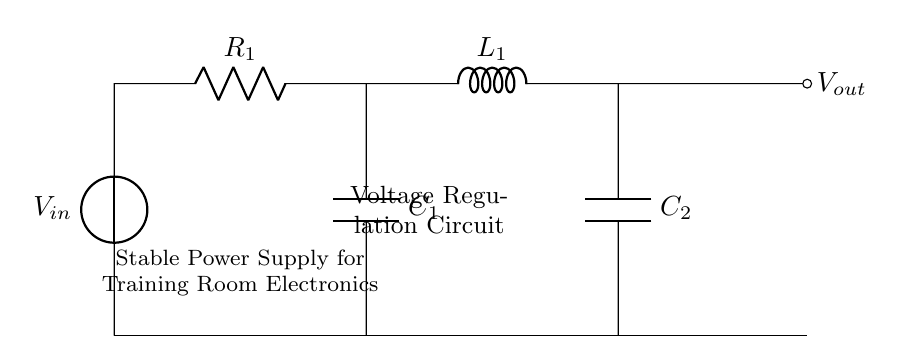What is the input voltage of the circuit? The input voltage is denoted as V_in in the circuit diagram, which is the voltage source connected at the left side of the circuit.
Answer: V_in What components are used for voltage regulation in this circuit? The components used for voltage regulation include a resistor, an inductor, and two capacitors. These are responsible for smoothing out the voltage fluctuations.
Answer: Resistor, Inductor, Capacitors How many capacitors are present in the circuit? By observing the diagram, we can see that there are two distinct capacitors connected in parallel, labeled as C_1 and C_2.
Answer: Two What is the function of the inductor in this circuit? The inductor's function is to store energy in a magnetic field when current passes through it, which helps in smoothing the current flow and reducing fluctuations.
Answer: Energy storage What is the purpose of the resistor in the voltage regulation circuit? The resistor is used to limit the current flowing through the circuit, which helps in controlling the voltage across the other components and maintaining stability.
Answer: Current limiting In a series combination, how do resistors affect total resistance? In a series combination like this, the total resistance is the sum of individual resistances, which increases the overall resistance of the circuit and can affect current flow based on Ohm's law.
Answer: Total resistance increases 